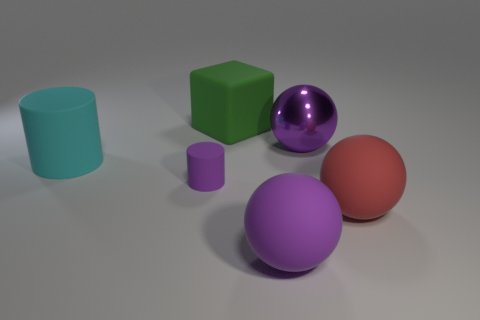Is there anything else that has the same shape as the big green thing?
Your response must be concise. No. There is a matte ball that is the same color as the metallic object; what size is it?
Provide a succinct answer. Large. What is the size of the object that is on the right side of the big cyan matte cylinder and on the left side of the large green block?
Your response must be concise. Small. Are there more big objects that are behind the purple matte sphere than green cubes?
Offer a terse response. Yes. What number of balls are either large objects or small rubber things?
Give a very brief answer. 3. What shape is the big thing that is on the right side of the large rubber cube and behind the cyan matte object?
Your response must be concise. Sphere. Is the number of purple rubber cylinders that are behind the metallic ball the same as the number of purple shiny objects that are in front of the large cyan object?
Ensure brevity in your answer.  Yes. What number of things are either big cylinders or tiny brown spheres?
Offer a very short reply. 1. What is the color of the shiny ball that is the same size as the green object?
Offer a terse response. Purple. What number of objects are rubber balls on the left side of the purple metal ball or purple matte objects that are in front of the large red object?
Offer a very short reply. 1. 